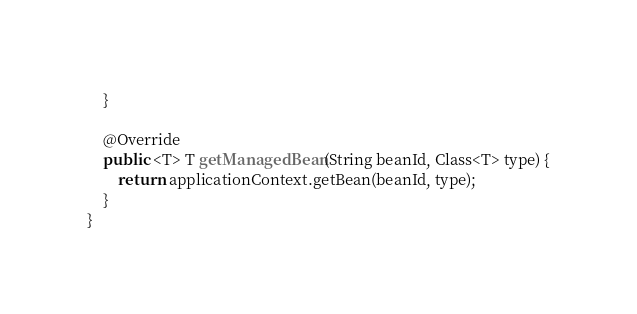<code> <loc_0><loc_0><loc_500><loc_500><_Java_>    }

    @Override
    public <T> T getManagedBean(String beanId, Class<T> type) {
    	return applicationContext.getBean(beanId, type);
    }
}
</code> 